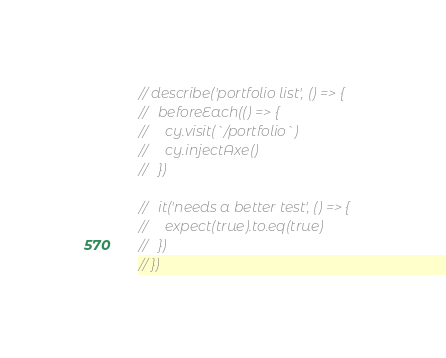Convert code to text. <code><loc_0><loc_0><loc_500><loc_500><_JavaScript_>// describe('portfolio list', () => {
//   beforeEach(() => {
//     cy.visit(`/portfolio`)
//     cy.injectAxe()
//   })

//   it('needs a better test', () => {
//     expect(true).to.eq(true)
//   })
// })</code> 